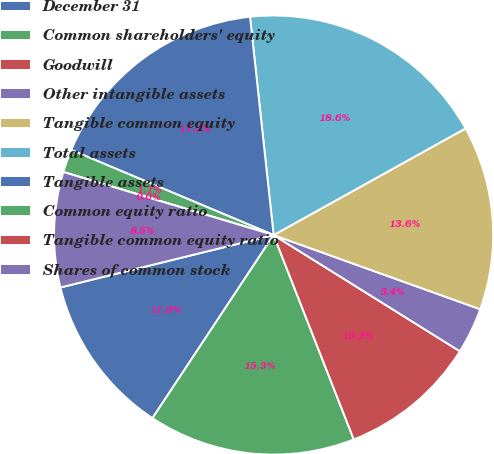<chart> <loc_0><loc_0><loc_500><loc_500><pie_chart><fcel>December 31<fcel>Common shareholders' equity<fcel>Goodwill<fcel>Other intangible assets<fcel>Tangible common equity<fcel>Total assets<fcel>Tangible assets<fcel>Common equity ratio<fcel>Tangible common equity ratio<fcel>Shares of common stock<nl><fcel>11.86%<fcel>15.25%<fcel>10.17%<fcel>3.39%<fcel>13.56%<fcel>18.64%<fcel>16.95%<fcel>1.7%<fcel>0.0%<fcel>8.47%<nl></chart> 